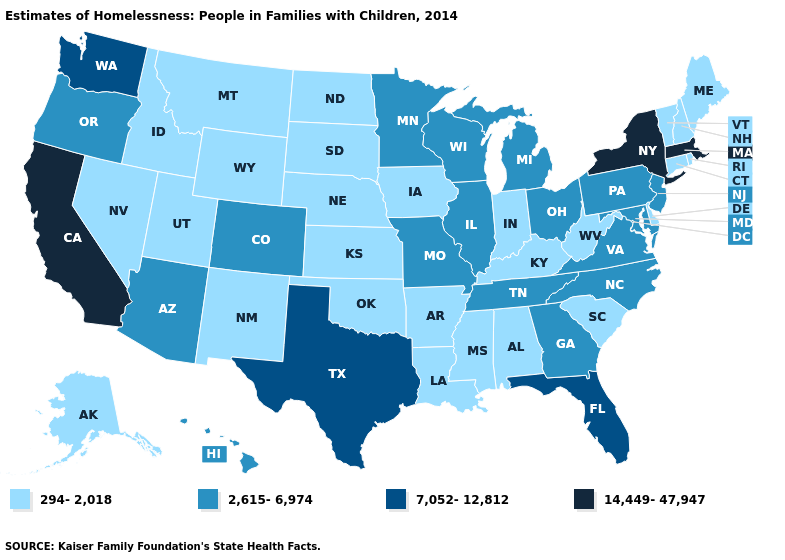What is the lowest value in the MidWest?
Concise answer only. 294-2,018. Name the states that have a value in the range 294-2,018?
Answer briefly. Alabama, Alaska, Arkansas, Connecticut, Delaware, Idaho, Indiana, Iowa, Kansas, Kentucky, Louisiana, Maine, Mississippi, Montana, Nebraska, Nevada, New Hampshire, New Mexico, North Dakota, Oklahoma, Rhode Island, South Carolina, South Dakota, Utah, Vermont, West Virginia, Wyoming. Does Oregon have a lower value than Nebraska?
Answer briefly. No. Name the states that have a value in the range 2,615-6,974?
Keep it brief. Arizona, Colorado, Georgia, Hawaii, Illinois, Maryland, Michigan, Minnesota, Missouri, New Jersey, North Carolina, Ohio, Oregon, Pennsylvania, Tennessee, Virginia, Wisconsin. Name the states that have a value in the range 2,615-6,974?
Answer briefly. Arizona, Colorado, Georgia, Hawaii, Illinois, Maryland, Michigan, Minnesota, Missouri, New Jersey, North Carolina, Ohio, Oregon, Pennsylvania, Tennessee, Virginia, Wisconsin. What is the lowest value in states that border Kentucky?
Write a very short answer. 294-2,018. Name the states that have a value in the range 2,615-6,974?
Write a very short answer. Arizona, Colorado, Georgia, Hawaii, Illinois, Maryland, Michigan, Minnesota, Missouri, New Jersey, North Carolina, Ohio, Oregon, Pennsylvania, Tennessee, Virginia, Wisconsin. Name the states that have a value in the range 2,615-6,974?
Concise answer only. Arizona, Colorado, Georgia, Hawaii, Illinois, Maryland, Michigan, Minnesota, Missouri, New Jersey, North Carolina, Ohio, Oregon, Pennsylvania, Tennessee, Virginia, Wisconsin. Does California have the highest value in the West?
Write a very short answer. Yes. Does Michigan have a lower value than Alaska?
Quick response, please. No. Does Virginia have the same value as Ohio?
Write a very short answer. Yes. How many symbols are there in the legend?
Be succinct. 4. Among the states that border South Dakota , which have the lowest value?
Quick response, please. Iowa, Montana, Nebraska, North Dakota, Wyoming. Name the states that have a value in the range 14,449-47,947?
Answer briefly. California, Massachusetts, New York. What is the value of Alaska?
Quick response, please. 294-2,018. 